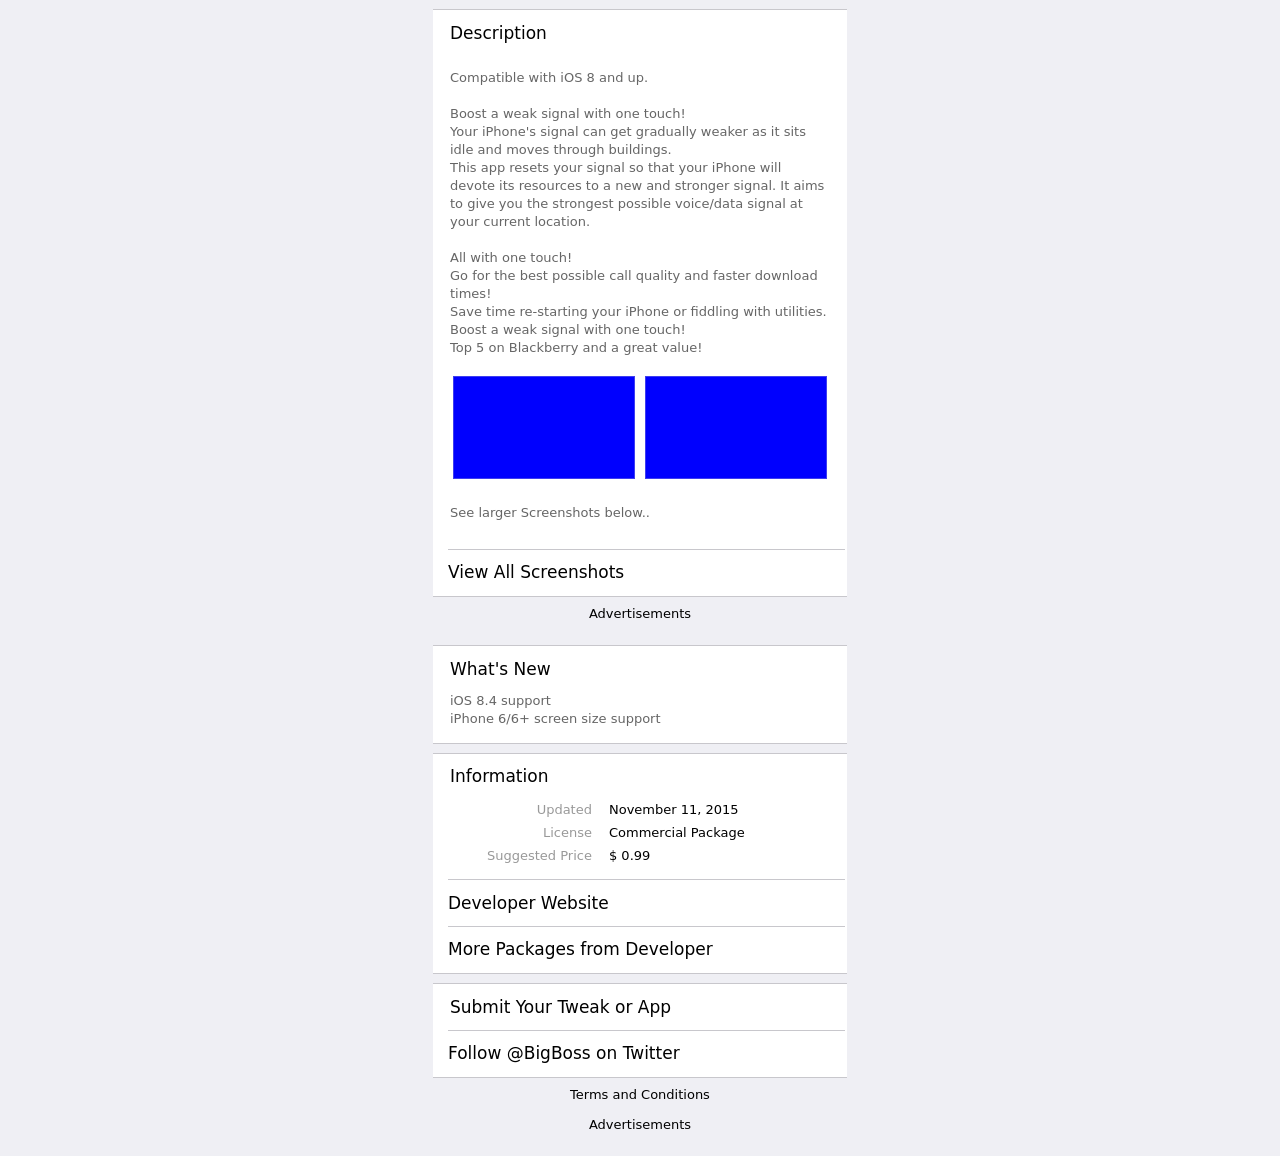How can I start building this website with HTML from the ground up? To begin building a website with HTML from the ground up, start by setting up a basic HTML template. Start with a 'doctype' declaration, then create the html tag, which contains the head and body. Inside the head, add a title and any necessary metadata. In the body section, you'll start with your content using tags like h1 for headers, p for paragraphs, and a for links. Add a link to your CSS stylesheet within the head to style the page. Here's an example of a simple HTML skeleton:

```html
<!DOCTYPE html>
<html>
<head>
  <title>Your Website Title Here</title>
  <link rel="stylesheet" type="text/css" href="styles.css">
</head>
<body>
  <h1>Welcome to My Website</h1>
  <p>This is a paragraph with some introductory text about the site.</p>
  <!-- Add more content here -->
</body>
</html>
``` 